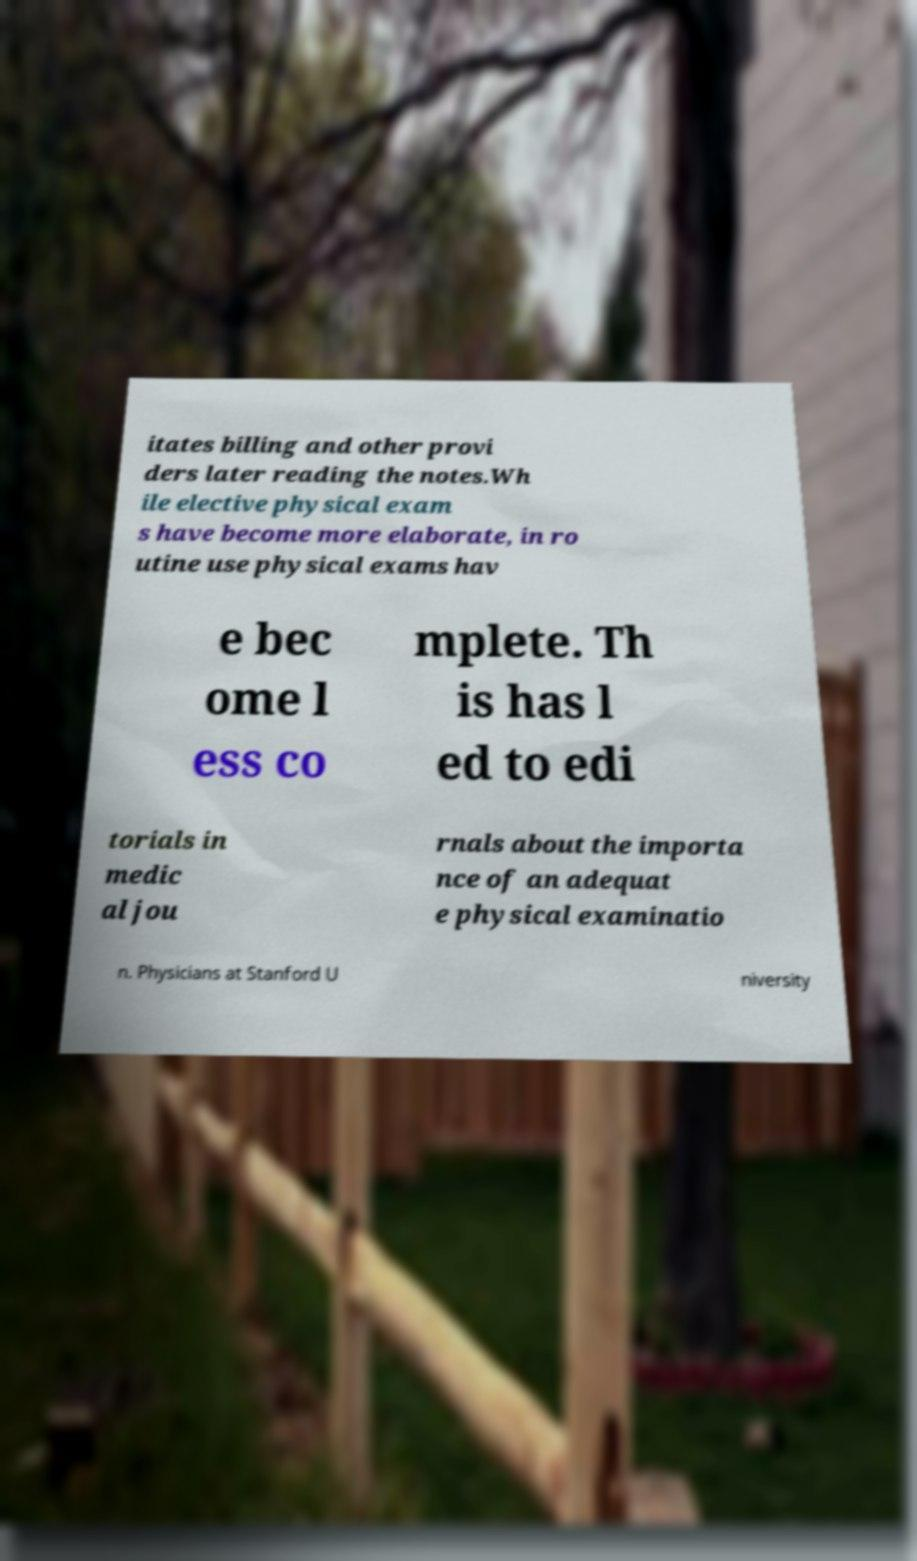I need the written content from this picture converted into text. Can you do that? itates billing and other provi ders later reading the notes.Wh ile elective physical exam s have become more elaborate, in ro utine use physical exams hav e bec ome l ess co mplete. Th is has l ed to edi torials in medic al jou rnals about the importa nce of an adequat e physical examinatio n. Physicians at Stanford U niversity 